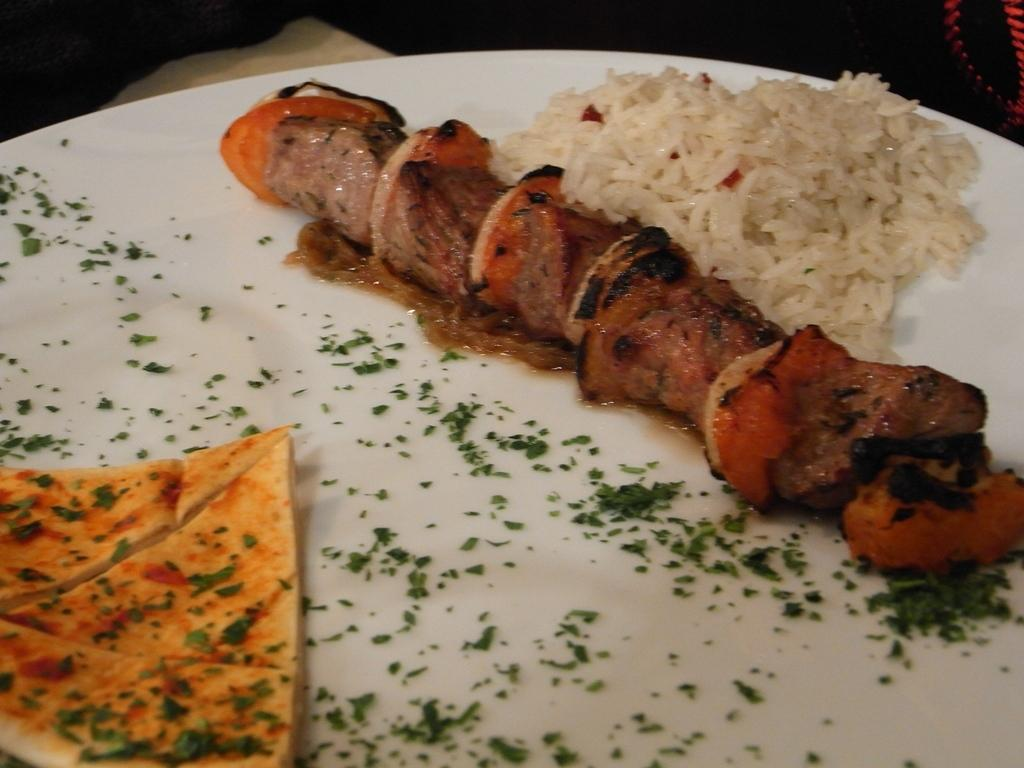What is on the plate in the image? There are food items on a plate, including rice. What color is the plate? The plate is white. Can you see a river flowing in the background of the image? There is no river visible in the image; it only shows a plate with food items. 